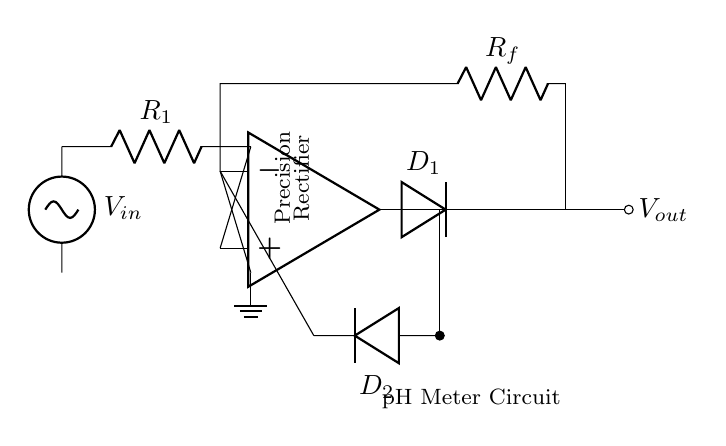What is the input voltage for this circuit? The input voltage is denoted as V_in, which is connected to the circuit at the left side.
Answer: V_in What are the two diodes used in this circuit? The circuit includes D_1 and D_2, which are indicated on the right side of the op-amp output.
Answer: D_1 and D_2 What is the function of the operational amplifier in this circuit? The operational amplifier amplifies the input voltage according to the feedback and input resistances, enabling precise rectification.
Answer: Amplifies What is the role of resistor R_f in the circuit? Resistor R_f is part of the feedback loop of the op-amp, determining the gain of the precision rectifier and influencing the output voltage.
Answer: Feedback gain How does this circuit provide accurate rectification for a pH meter? This circuit provides accurate rectification by using an operational amplifier in conjunction with diodes, which allows it to respond to both positive and negative input signals effectively, ensuring that the precise output reflects the actual pH measurement.
Answer: Accurate rectification What type of rectifier is this circuit designed to be? This circuit is designed to be a precision rectifier, which is specifically used for applications requiring accurate handling of small voltage signals, such as pH measurements.
Answer: Precision rectifier 